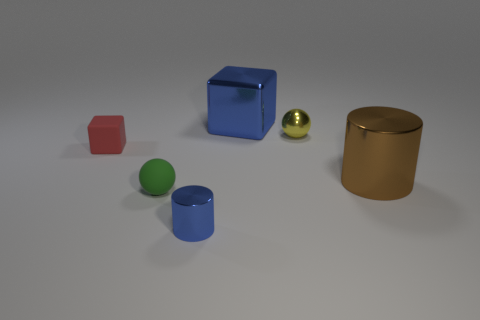Are there any large shiny blocks of the same color as the tiny cylinder?
Your answer should be very brief. Yes. Is the cylinder to the left of the metallic sphere made of the same material as the small green object?
Keep it short and to the point. No. The small red thing is what shape?
Your answer should be very brief. Cube. Is the number of large shiny things that are behind the tiny shiny sphere greater than the number of big red rubber blocks?
Make the answer very short. Yes. The other metal thing that is the same shape as the green object is what color?
Your response must be concise. Yellow. There is a large object in front of the tiny red matte block; what shape is it?
Your answer should be very brief. Cylinder. There is a rubber sphere; are there any blocks to the right of it?
Your response must be concise. Yes. What is the color of the tiny cylinder that is the same material as the large cube?
Ensure brevity in your answer.  Blue. There is a big metallic object left of the tiny shiny ball; is its color the same as the shiny thing that is in front of the green ball?
Your answer should be very brief. Yes. How many blocks are either blue matte objects or yellow objects?
Offer a terse response. 0. 